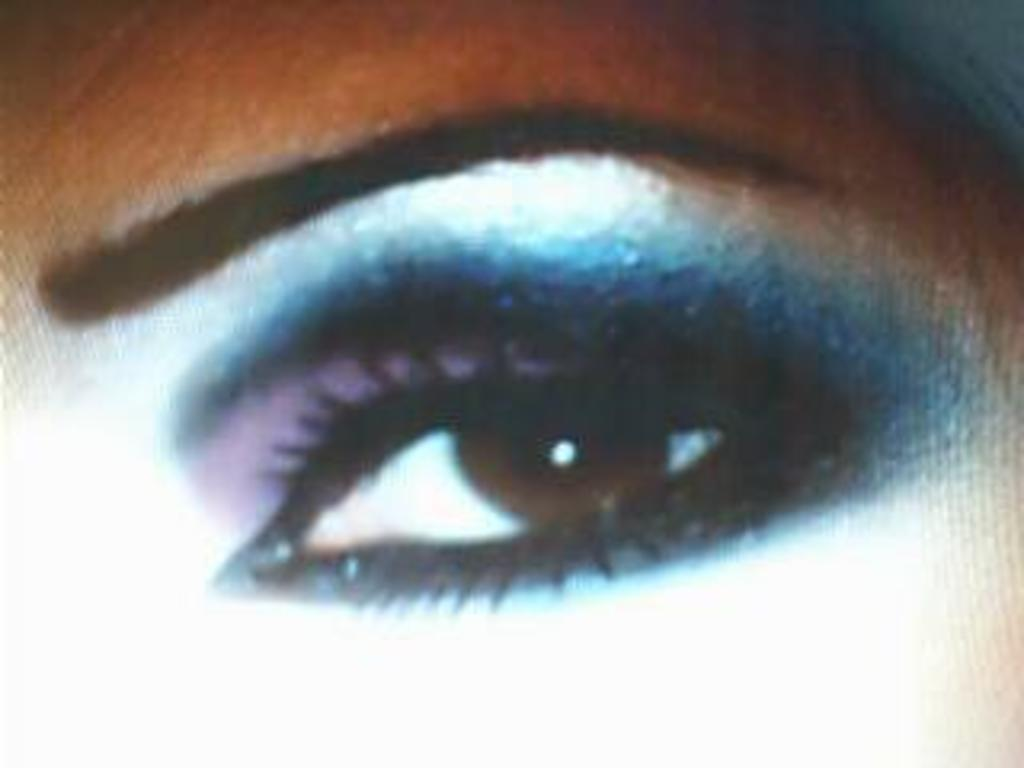What is the main subject of the image? The main subject of the image is an eye. To whom does the eye belong? The eye belongs to a woman. What letter is the woman holding in her hand in the image? There is no letter present in the image; it only features a woman's eye. What relation does the woman have with the person taking the picture in the image? There is no information about the woman's relation to anyone else in the image. --- Facts: 1. There is a car in the image. 2. The car is red. 3. The car has four wheels. 4. The car has a license plate. 5. The license plate has numbers and letters. Absurd Topics: bird, ocean, mountain Conversation: What is the main subject of the image? The main subject of the image is a car. What color is the car? The car is red. How many wheels does the car have? The car has four wheels. Does the car have a license plate? Yes, the car has a license plate. What is written on the license plate? The license plate has numbers and letters. Reasoning: Let's think step by step in order to produce the conversation. We start by identifying the main subject of the image, which is the car. Then, we provide additional information about the car, specifying its color, the number of wheels, and the presence of a license plate. Finally, we describe the contents of the license plate, which are numbers and letters. Each question is designed to elicit a specific detail about the image that is known from the provided facts. Absurd Question/Answer: Can you see any birds flying over the ocean in the image? There is no ocean or birds present in the image; it only features a red car with a license plate. Is there a mountain visible in the background of the image? There is no mountain visible in the image; it only features a red car with a license plate. 